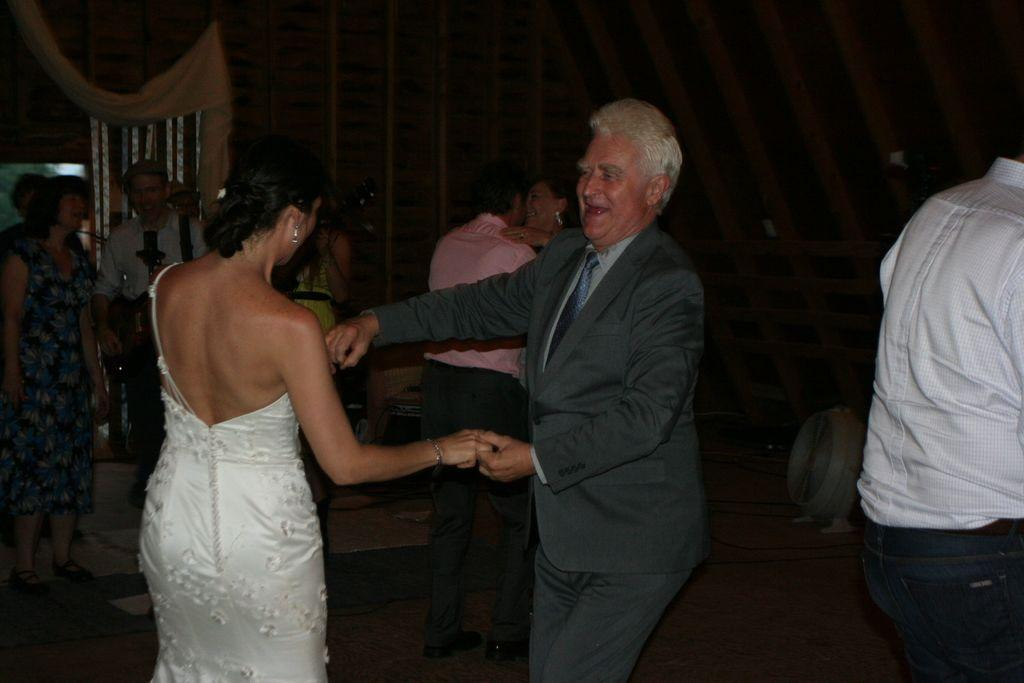What are the people in the image doing? The people in the image are dancing. What instrument is being played by one of the people in the image? A man is playing a guitar in the image. Are there any other musicians in the image? Yes, a woman is also playing a guitar in the image. How many mice can be seen dancing with the people in the image? There are no mice present in the image; it features people dancing and musicians playing guitars. What type of girl is playing the guitar in the image? There is no specific girl mentioned in the image; it only states that a woman is playing a guitar. 